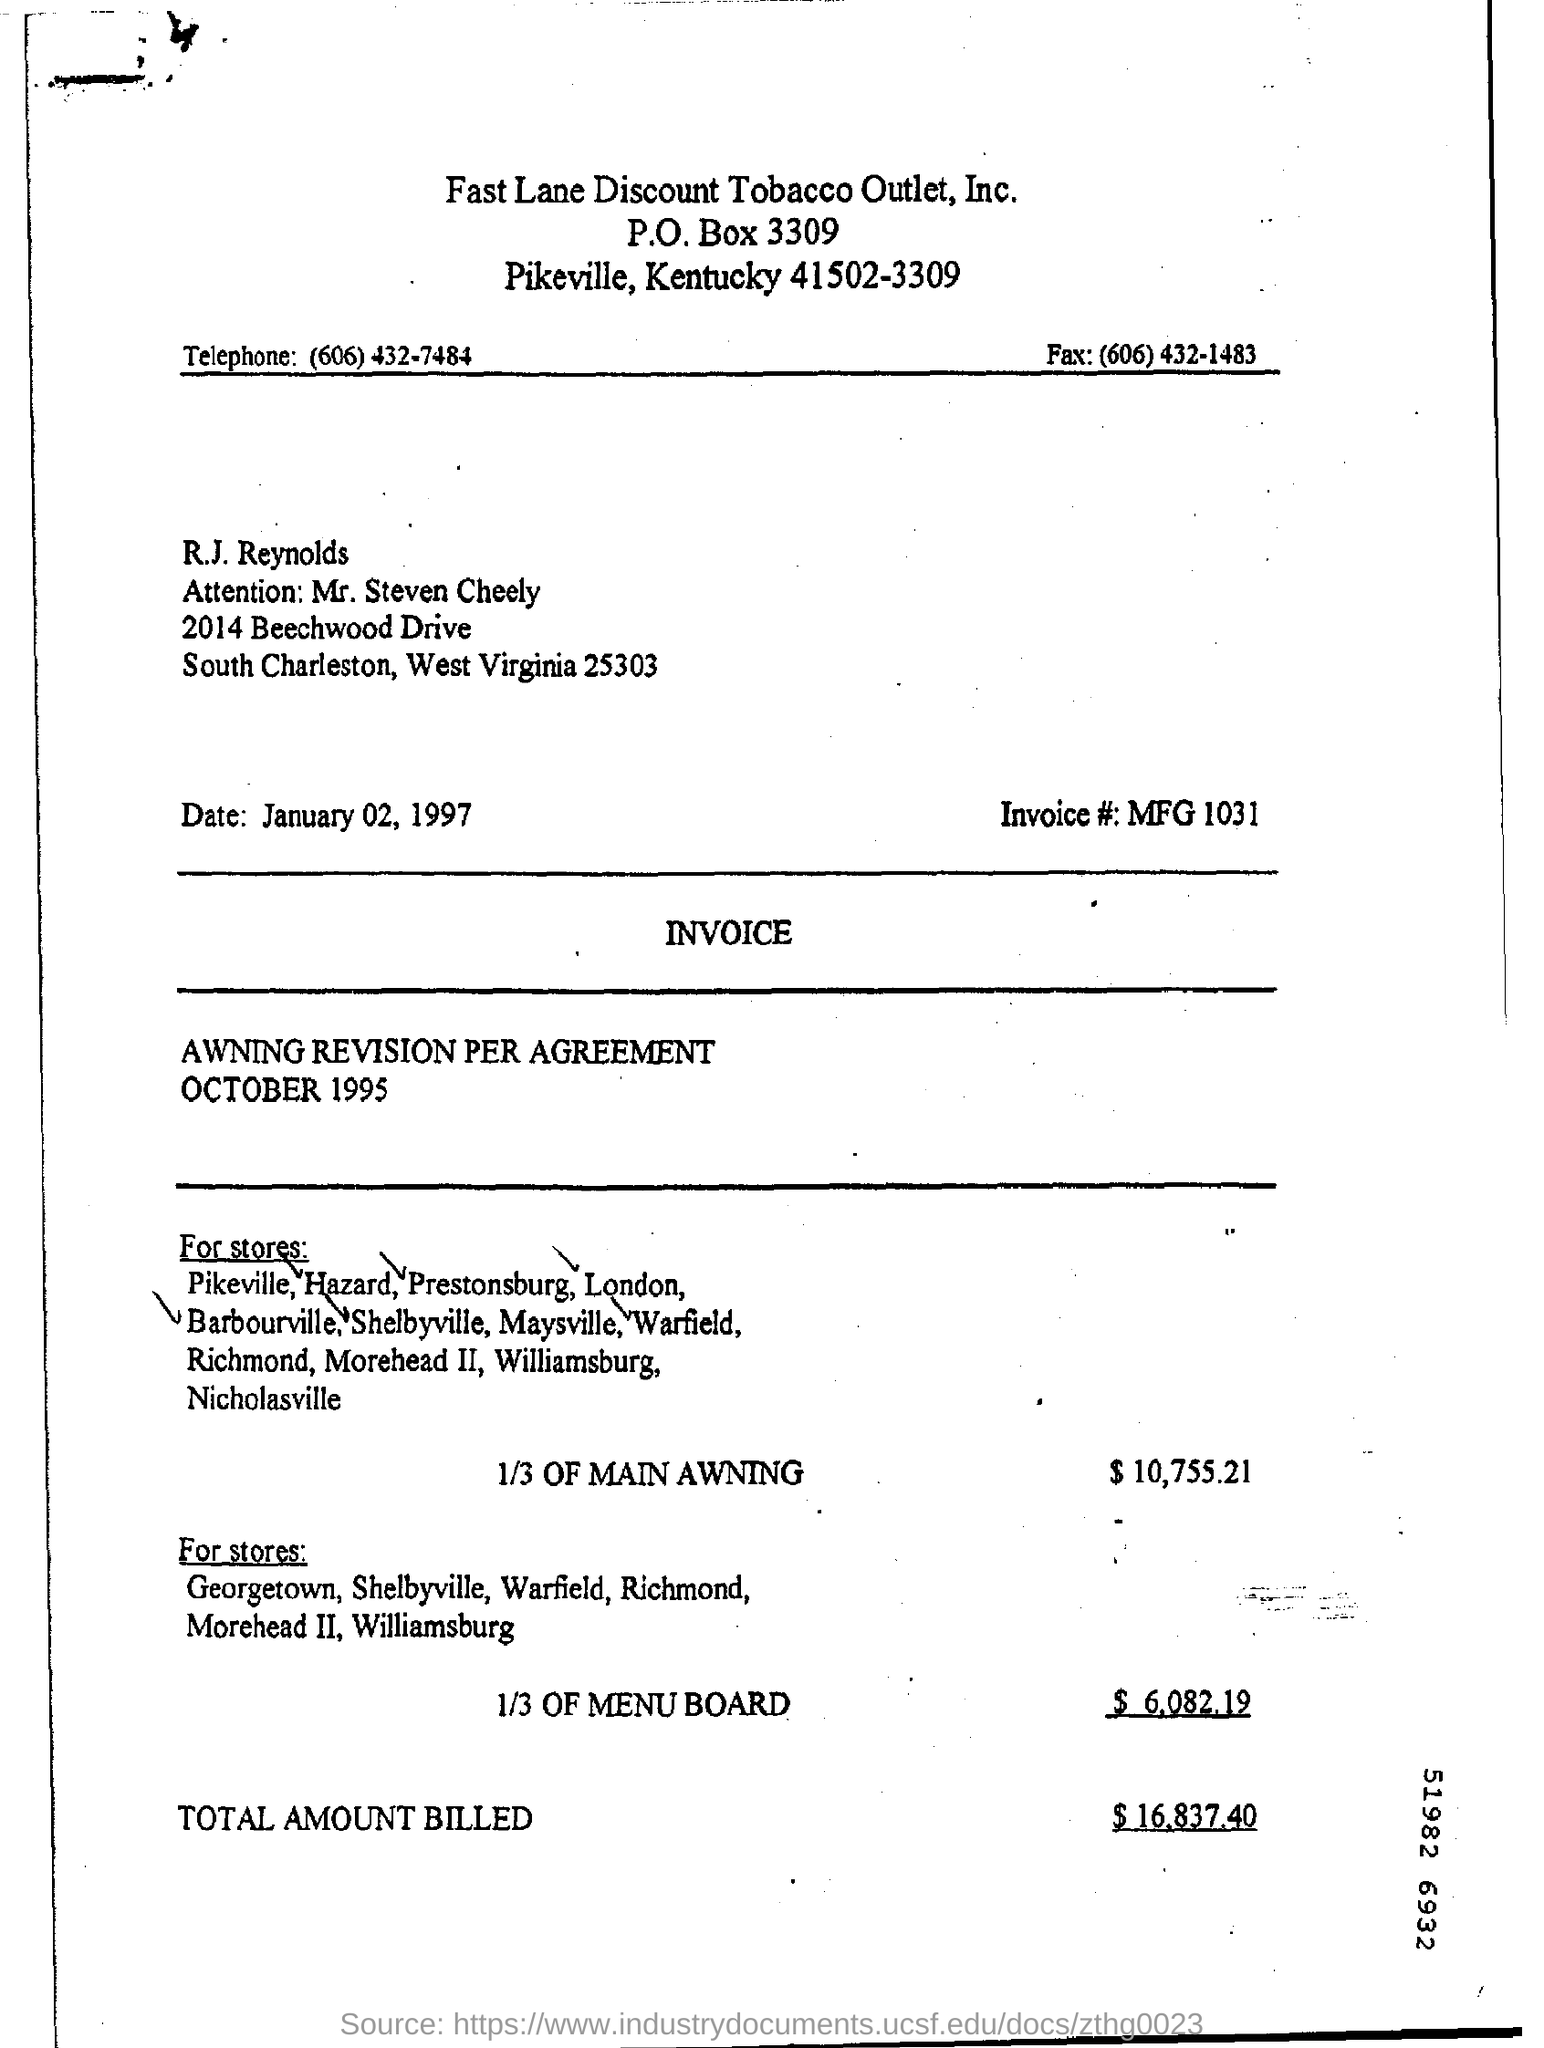Draw attention to some important aspects in this diagram. This is a letterhead from Fast Lane Discount Tobacco Outlet, Inc. The invoice number is 1031. The amount for 1/3 of the menu board is $6,082.19. The tobacco outlet's fax number is (606) 432-1483. The telephone number is (606) 432-7484. 